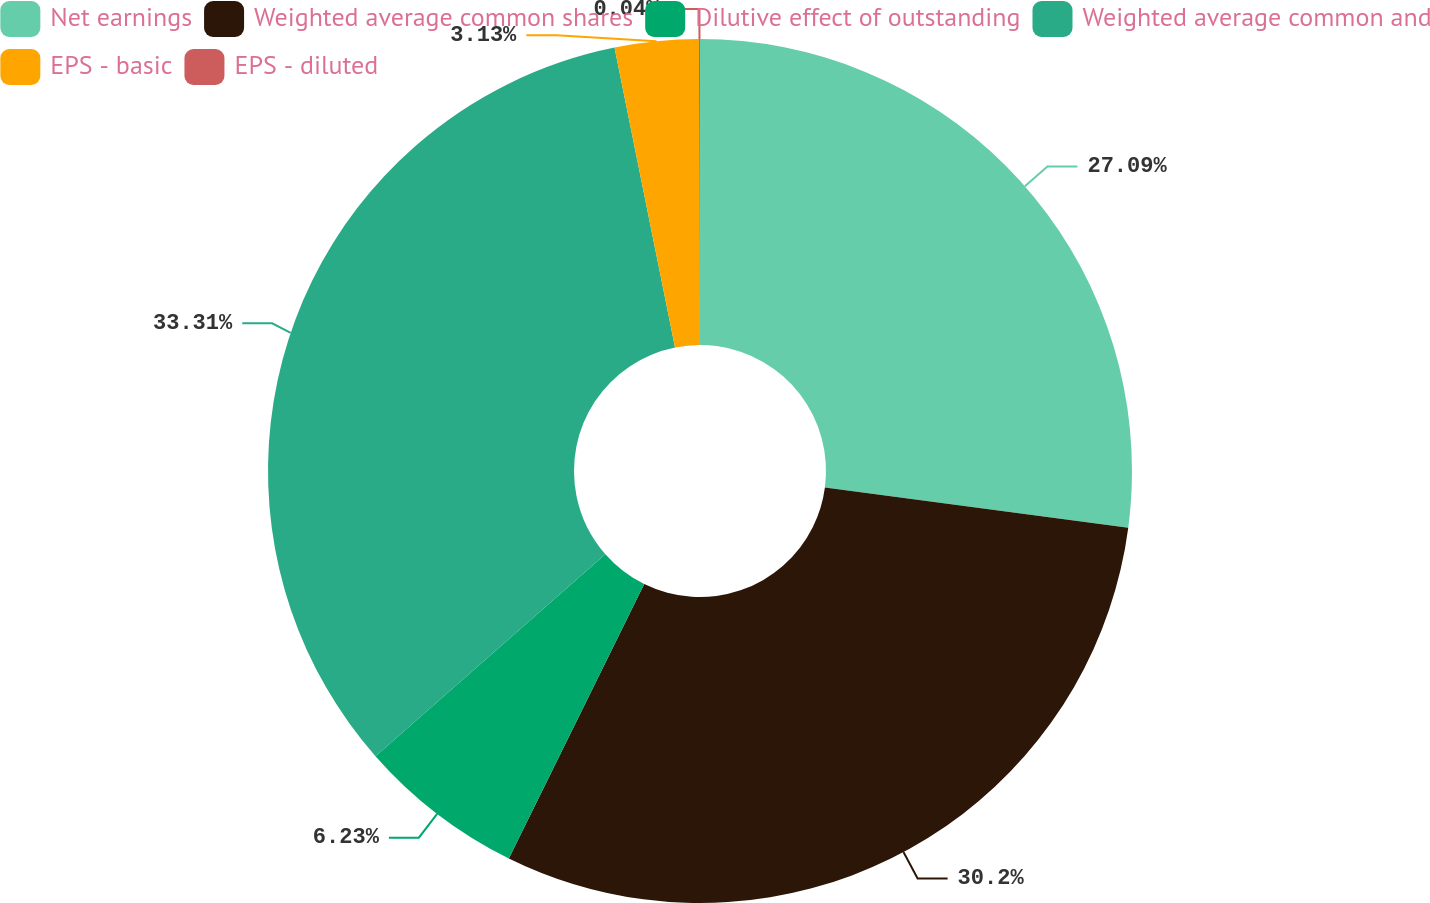Convert chart. <chart><loc_0><loc_0><loc_500><loc_500><pie_chart><fcel>Net earnings<fcel>Weighted average common shares<fcel>Dilutive effect of outstanding<fcel>Weighted average common and<fcel>EPS - basic<fcel>EPS - diluted<nl><fcel>27.09%<fcel>30.2%<fcel>6.23%<fcel>33.3%<fcel>3.13%<fcel>0.04%<nl></chart> 